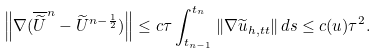Convert formula to latex. <formula><loc_0><loc_0><loc_500><loc_500>\left \| \nabla ( \overline { \widetilde { U } } ^ { n } - \widetilde { U } ^ { n - \frac { 1 } { 2 } } ) \right \| \leq c \tau \int _ { t _ { n - 1 } } ^ { t _ { n } } \| \nabla \widetilde { u } _ { h , t t } \| \, d s \leq c ( u ) \tau ^ { 2 } .</formula> 